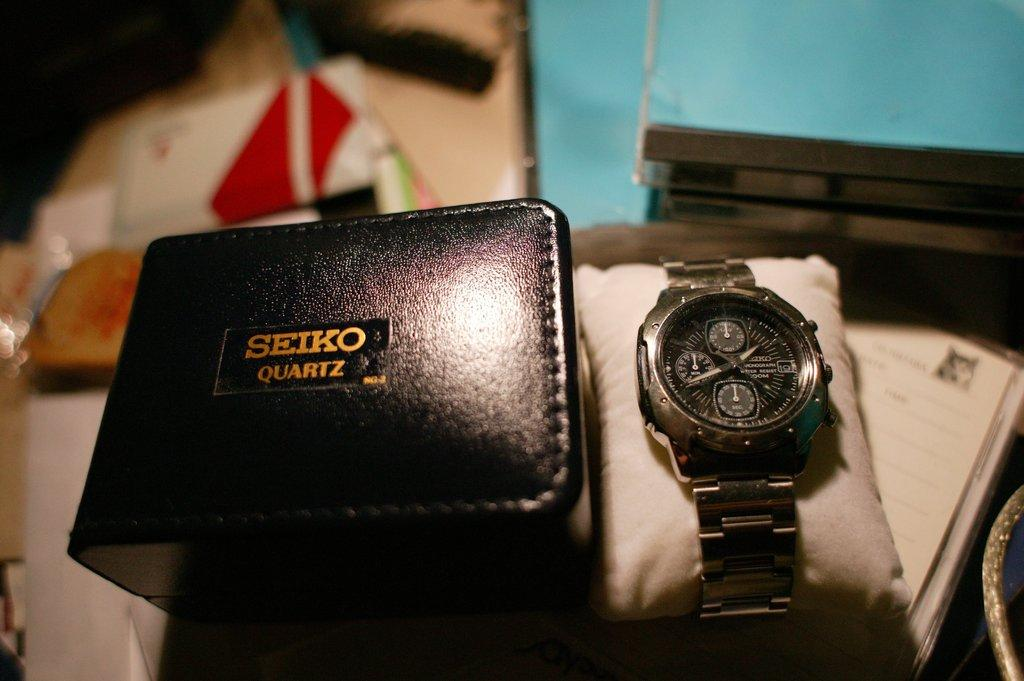<image>
Provide a brief description of the given image. A black watch freshly unboxed from Seiko Quartz. 